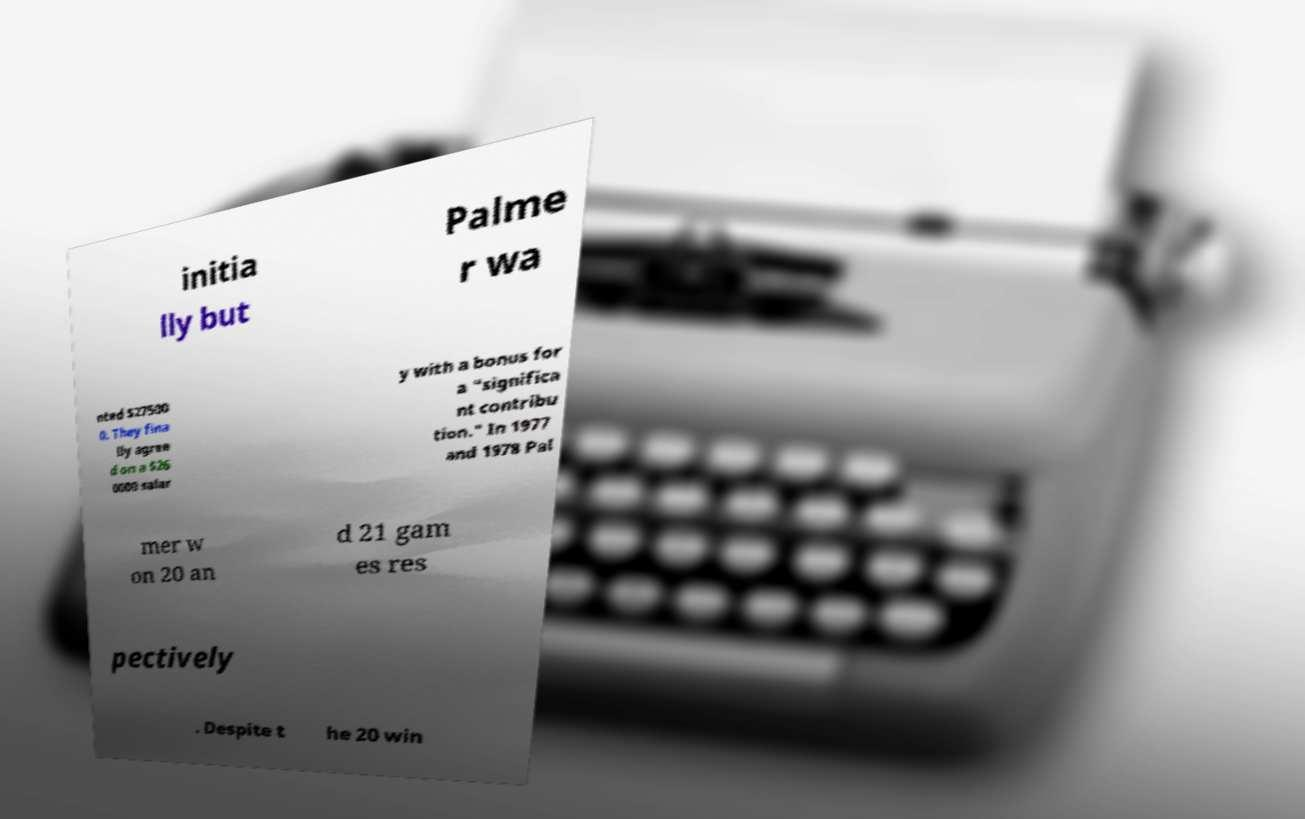I need the written content from this picture converted into text. Can you do that? initia lly but Palme r wa nted $27500 0. They fina lly agree d on a $26 0000 salar y with a bonus for a "significa nt contribu tion." In 1977 and 1978 Pal mer w on 20 an d 21 gam es res pectively . Despite t he 20 win 